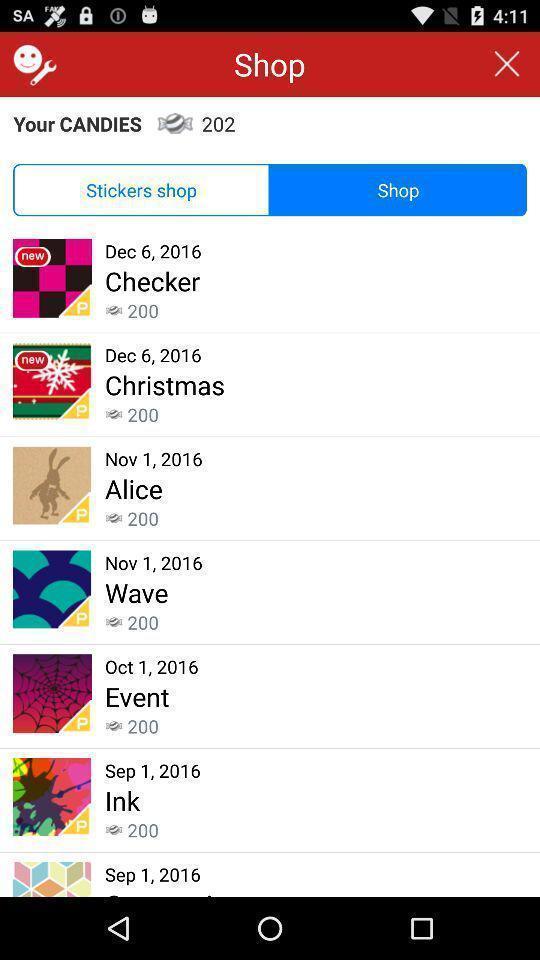Please provide a description for this image. Set of options in a private business app. 